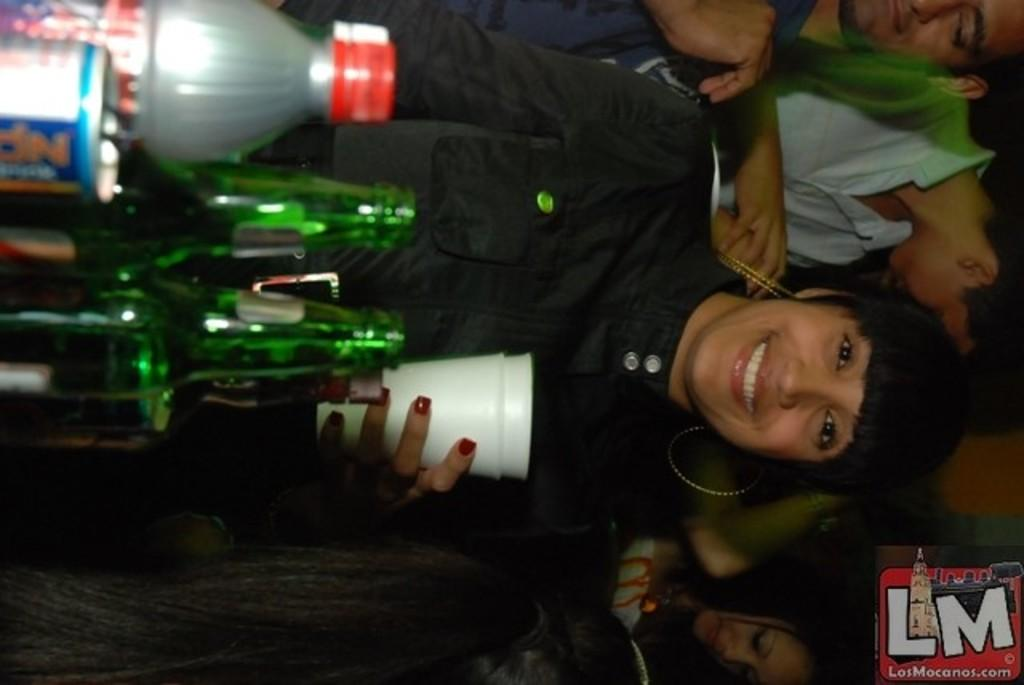How many people are in the image? There are people in the image, but the exact number is not specified. What is one person holding in the image? One person is holding a glass in the image. What else can be seen in the image besides the people? There is a bottle in the image. What type of collar can be seen on the actor in the image? There is no actor or collar present in the image. What type of bushes are visible in the background of the image? There is no mention of bushes or a background in the provided facts, so we cannot determine if they are present in the image. 